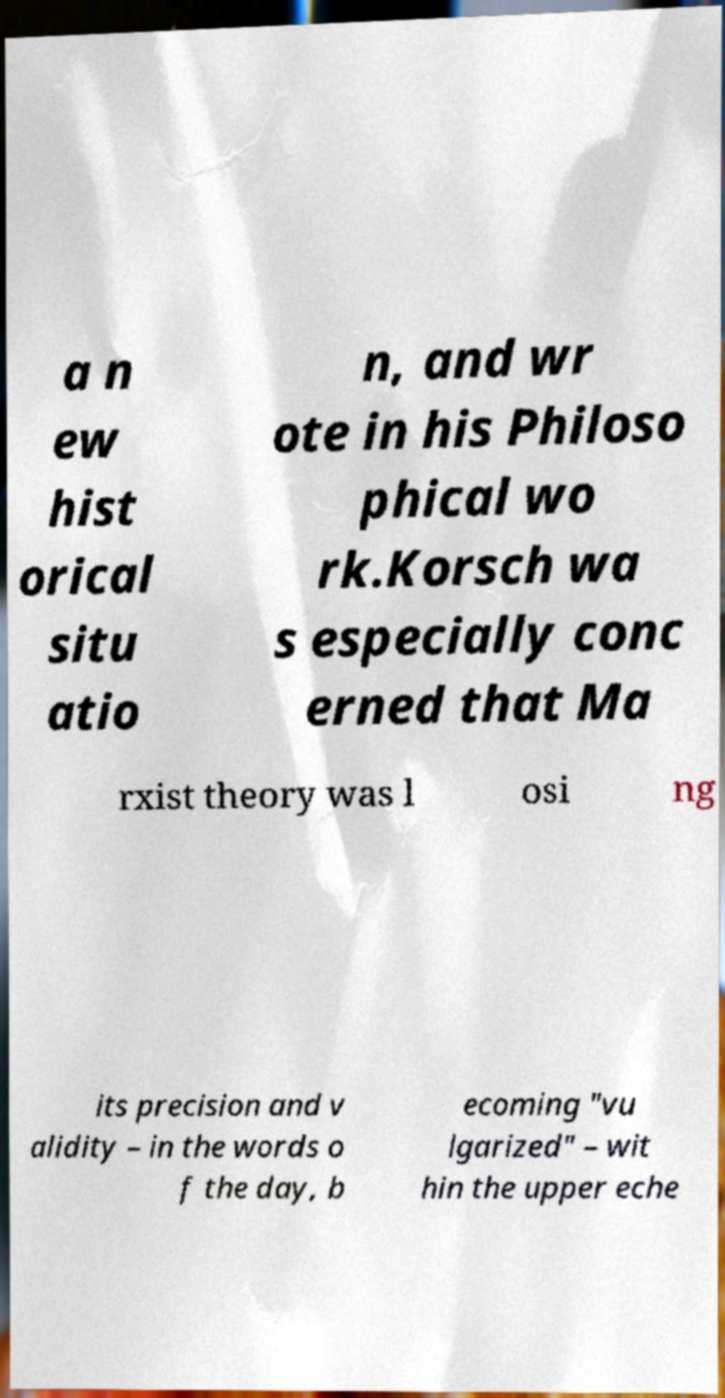Could you extract and type out the text from this image? a n ew hist orical situ atio n, and wr ote in his Philoso phical wo rk.Korsch wa s especially conc erned that Ma rxist theory was l osi ng its precision and v alidity – in the words o f the day, b ecoming "vu lgarized" – wit hin the upper eche 